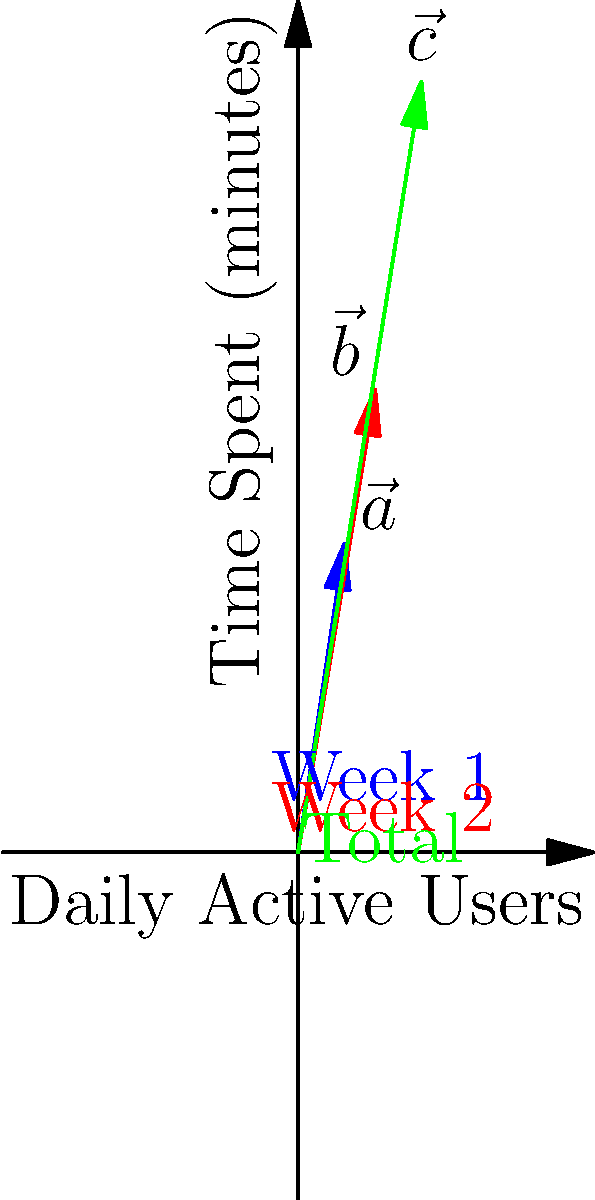Your Ember.js dashboard displays user engagement metrics using vector arrows. Vector $\vec{a}$ represents Week 1 data (3 million daily active users, 20 minutes average time spent), and $\vec{b}$ represents Week 2 data (5 million daily active users, 30 minutes average time spent). Calculate the magnitude of vector $\vec{c}$, which represents the total engagement over the two weeks. To solve this problem, we'll follow these steps:

1) First, we need to understand that vector $\vec{c}$ is the sum of vectors $\vec{a}$ and $\vec{b}$:
   $\vec{c} = \vec{a} + \vec{b}$

2) We're given:
   $\vec{a} = (3, 20)$
   $\vec{b} = (5, 30)$

3) To find $\vec{c}$, we add the corresponding components:
   $\vec{c} = (3+5, 20+30) = (8, 50)$

4) The magnitude of a vector $(x, y)$ is given by the formula:
   $\sqrt{x^2 + y^2}$

5) For $\vec{c} = (8, 50)$, we calculate:
   $\|\vec{c}\| = \sqrt{8^2 + 50^2}$

6) Simplify:
   $\|\vec{c}\| = \sqrt{64 + 2500} = \sqrt{2564}$

7) Calculate the square root:
   $\|\vec{c}\| \approx 50.64$

Therefore, the magnitude of vector $\vec{c}$, representing total engagement, is approximately 50.64.
Answer: $50.64$ 